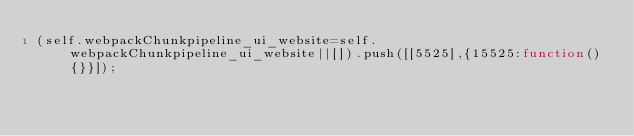Convert code to text. <code><loc_0><loc_0><loc_500><loc_500><_JavaScript_>(self.webpackChunkpipeline_ui_website=self.webpackChunkpipeline_ui_website||[]).push([[5525],{15525:function(){}}]);</code> 